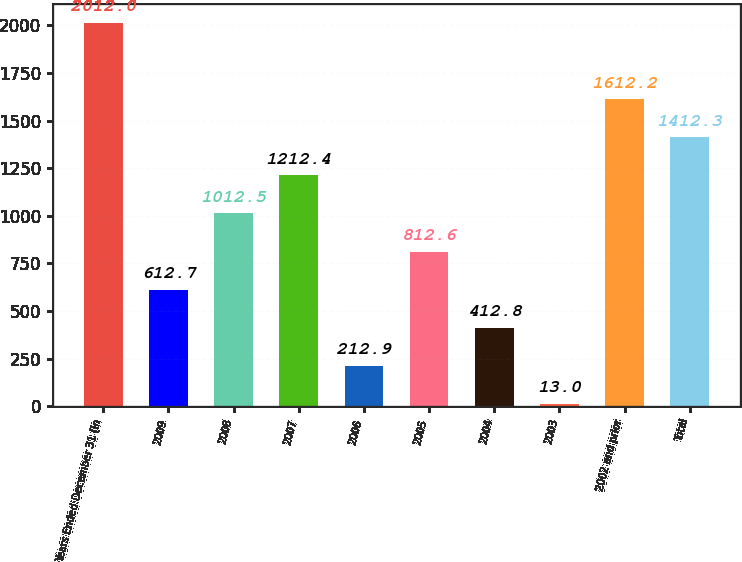Convert chart. <chart><loc_0><loc_0><loc_500><loc_500><bar_chart><fcel>Years Ended December 31 (in<fcel>2009<fcel>2008<fcel>2007<fcel>2006<fcel>2005<fcel>2004<fcel>2003<fcel>2002 and prior<fcel>Total<nl><fcel>2012<fcel>612.7<fcel>1012.5<fcel>1212.4<fcel>212.9<fcel>812.6<fcel>412.8<fcel>13<fcel>1612.2<fcel>1412.3<nl></chart> 